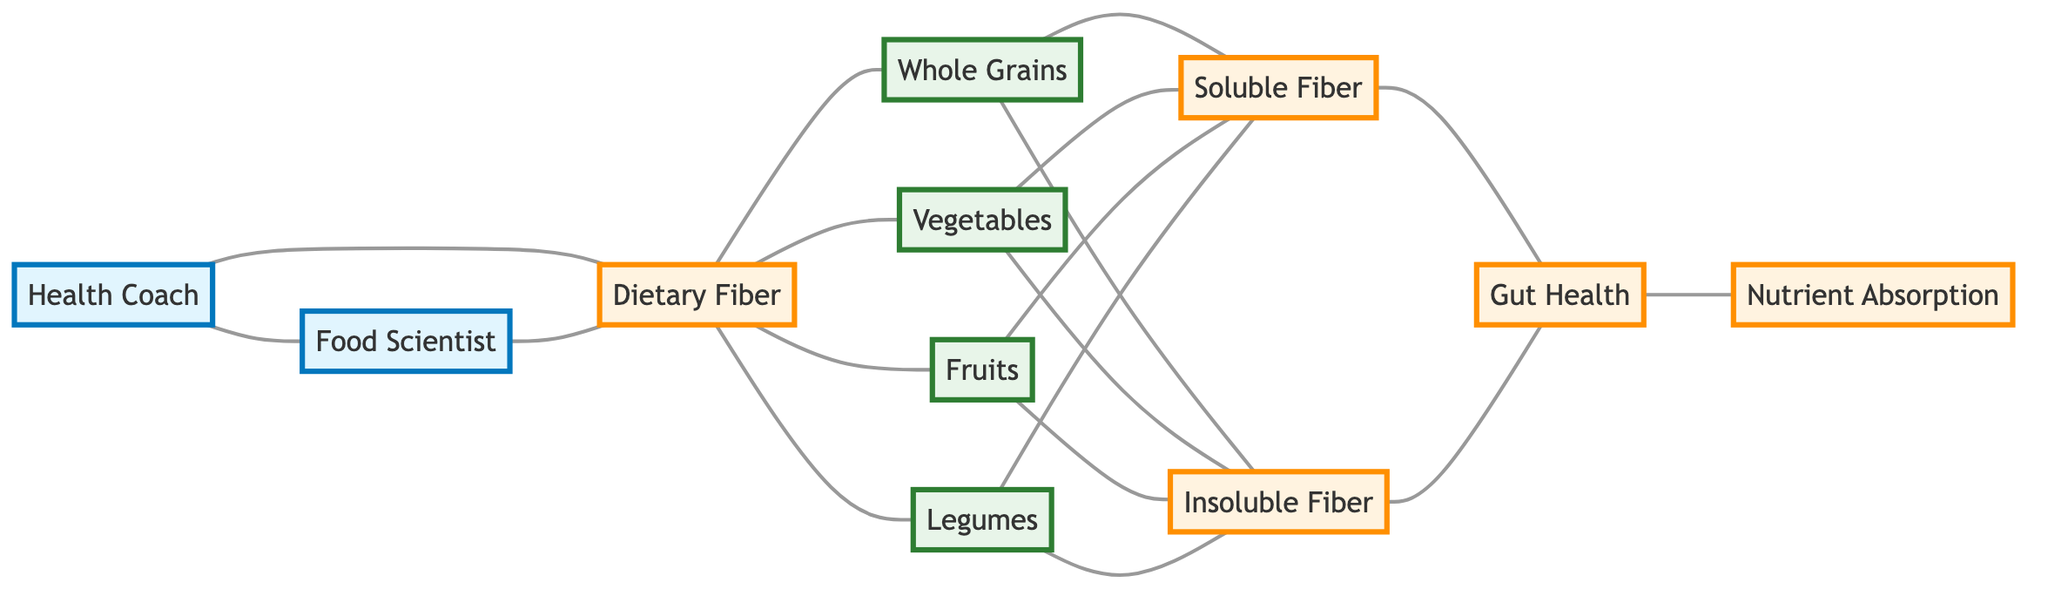What is the total number of nodes in the diagram? The diagram lists the following nodes: Health Coach, Food Scientist, Dietary Fiber, Whole Grains, Vegetables, Fruits, Legumes, Soluble Fiber, Insoluble Fiber, Gut Health, Nutrient Absorption. Counting these gives a total of 11 nodes.
Answer: 11 Which node is directly connected to Health Coach? The diagram shows that the Health Coach is connected to both Food Scientist and Dietary Fiber. Thus, the nodes directly connected to Health Coach are Food Scientist and Dietary Fiber.
Answer: Food Scientist and Dietary Fiber How many types of fiber are represented in the diagram? The diagram includes two types of fiber: Soluble Fiber and Insoluble Fiber. These nodes are connected to various sources of Dietary Fiber, thus highlighting that there are 2 types of fiber depicted.
Answer: 2 What nodes are connected to Dietary Fiber? From the diagram, Dietary Fiber is connected to Whole Grains, Vegetables, Fruits, and Legumes. Thus, the nodes connected to Dietary Fiber are Whole Grains, Vegetables, Fruits, and Legumes.
Answer: Whole Grains, Vegetables, Fruits, Legumes Which node connects Gut Health to Nutrient Absorption? The diagram indicates that Gut Health is directly connected to Nutrient Absorption, meaning that there is a direct path between these two nodes.
Answer: Gut Health Which sources lead to Soluble Fiber? The diagram shows that Soluble Fiber is derived from Whole Grains, Vegetables, Fruits, and Legumes, indicating multiple sources that provide Soluble Fiber.
Answer: Whole Grains, Vegetables, Fruits, Legumes Which node is connected to both types of fiber? Both the Soluble Fiber and Insoluble Fiber nodes are connected to Whole Grains, Vegetables, Fruits, and Legumes. Thus, those sources lead to both types of fiber.
Answer: Whole Grains, Vegetables, Fruits, Legumes How many edges are there in total in the diagram? The edges are the connections between the nodes, totaling up to 17 connections in the diagram. Each unique connection between nodes is counted as an edge.
Answer: 17 What relationship does Dietary Fiber have with Gut Health? The diagram shows that both types of fiber (Soluble and Insoluble) connect to Gut Health. Therefore, Dietary Fiber positively impacts Gut Health through these fibers.
Answer: Positive impact 